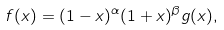Convert formula to latex. <formula><loc_0><loc_0><loc_500><loc_500>f ( x ) = ( 1 - x ) ^ { \alpha } ( 1 + x ) ^ { \beta } g ( x ) ,</formula> 